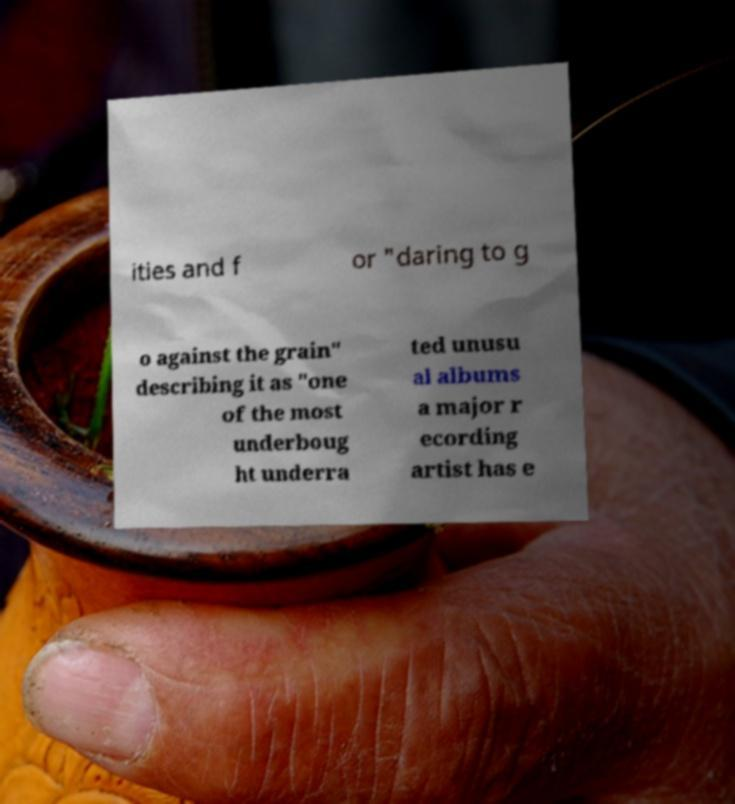Please read and relay the text visible in this image. What does it say? ities and f or "daring to g o against the grain" describing it as "one of the most underboug ht underra ted unusu al albums a major r ecording artist has e 